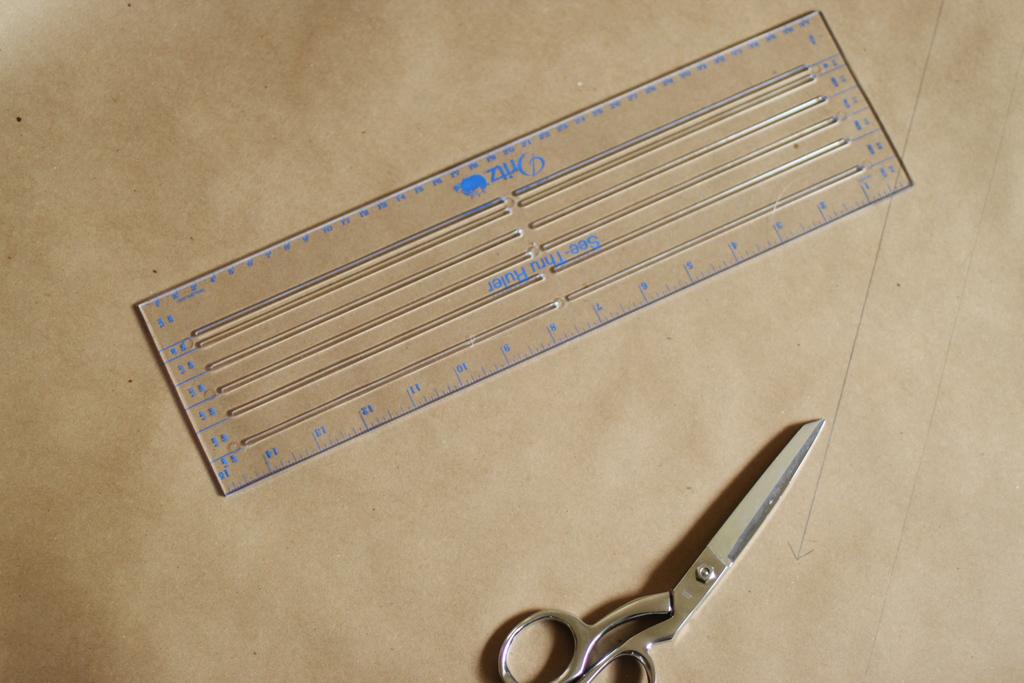What color are the scissors?
Make the answer very short. Answering does not require reading text in the image. How many inches long is this ruler?
Your response must be concise. 15. 